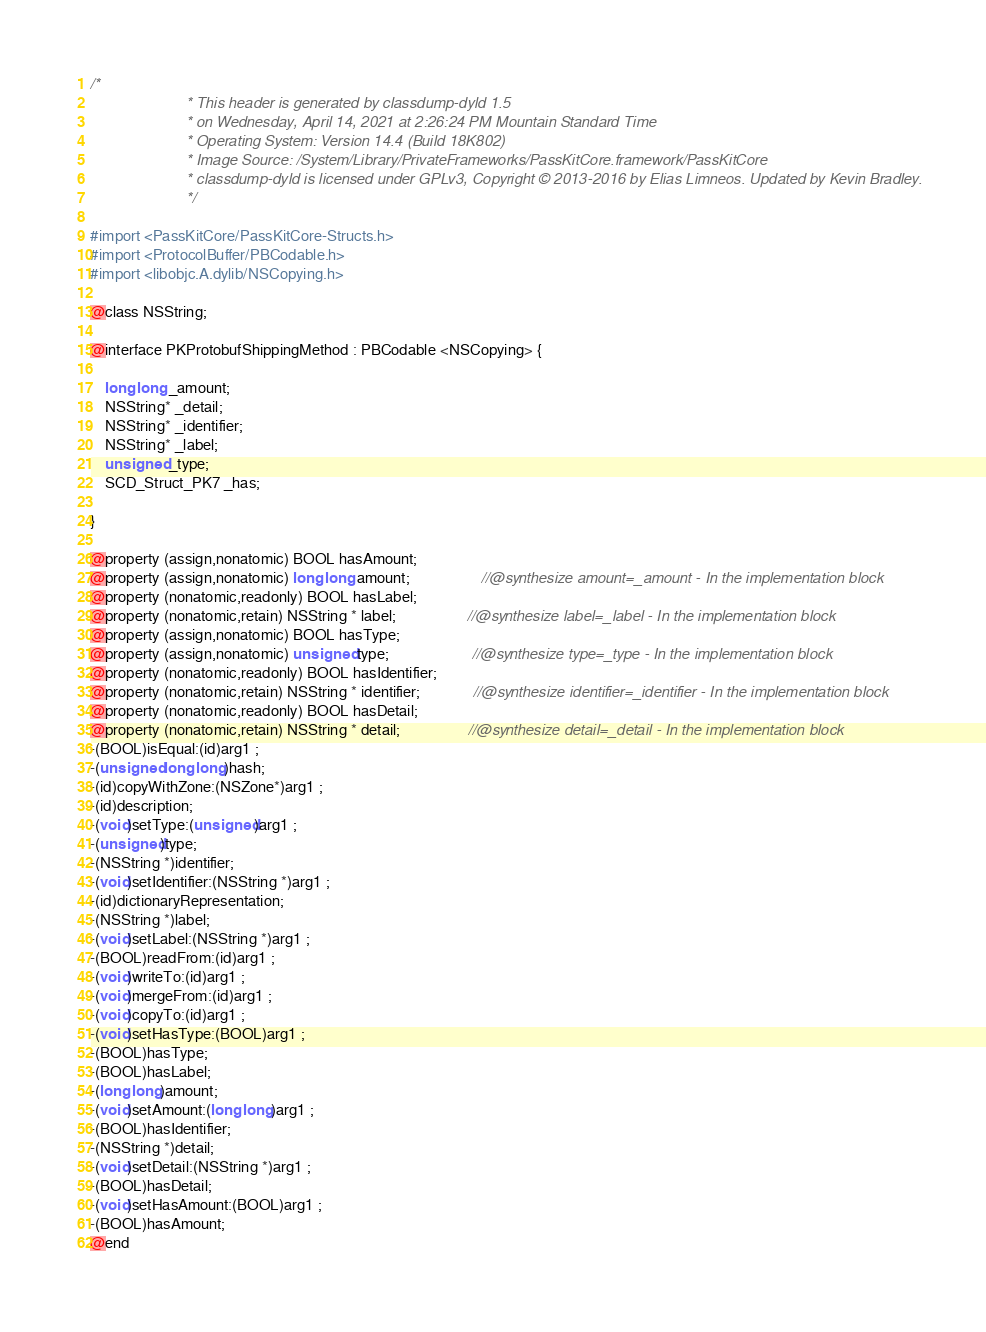<code> <loc_0><loc_0><loc_500><loc_500><_C_>/*
                       * This header is generated by classdump-dyld 1.5
                       * on Wednesday, April 14, 2021 at 2:26:24 PM Mountain Standard Time
                       * Operating System: Version 14.4 (Build 18K802)
                       * Image Source: /System/Library/PrivateFrameworks/PassKitCore.framework/PassKitCore
                       * classdump-dyld is licensed under GPLv3, Copyright © 2013-2016 by Elias Limneos. Updated by Kevin Bradley.
                       */

#import <PassKitCore/PassKitCore-Structs.h>
#import <ProtocolBuffer/PBCodable.h>
#import <libobjc.A.dylib/NSCopying.h>

@class NSString;

@interface PKProtobufShippingMethod : PBCodable <NSCopying> {

	long long _amount;
	NSString* _detail;
	NSString* _identifier;
	NSString* _label;
	unsigned _type;
	SCD_Struct_PK7 _has;

}

@property (assign,nonatomic) BOOL hasAmount; 
@property (assign,nonatomic) long long amount;                   //@synthesize amount=_amount - In the implementation block
@property (nonatomic,readonly) BOOL hasLabel; 
@property (nonatomic,retain) NSString * label;                   //@synthesize label=_label - In the implementation block
@property (assign,nonatomic) BOOL hasType; 
@property (assign,nonatomic) unsigned type;                      //@synthesize type=_type - In the implementation block
@property (nonatomic,readonly) BOOL hasIdentifier; 
@property (nonatomic,retain) NSString * identifier;              //@synthesize identifier=_identifier - In the implementation block
@property (nonatomic,readonly) BOOL hasDetail; 
@property (nonatomic,retain) NSString * detail;                  //@synthesize detail=_detail - In the implementation block
-(BOOL)isEqual:(id)arg1 ;
-(unsigned long long)hash;
-(id)copyWithZone:(NSZone*)arg1 ;
-(id)description;
-(void)setType:(unsigned)arg1 ;
-(unsigned)type;
-(NSString *)identifier;
-(void)setIdentifier:(NSString *)arg1 ;
-(id)dictionaryRepresentation;
-(NSString *)label;
-(void)setLabel:(NSString *)arg1 ;
-(BOOL)readFrom:(id)arg1 ;
-(void)writeTo:(id)arg1 ;
-(void)mergeFrom:(id)arg1 ;
-(void)copyTo:(id)arg1 ;
-(void)setHasType:(BOOL)arg1 ;
-(BOOL)hasType;
-(BOOL)hasLabel;
-(long long)amount;
-(void)setAmount:(long long)arg1 ;
-(BOOL)hasIdentifier;
-(NSString *)detail;
-(void)setDetail:(NSString *)arg1 ;
-(BOOL)hasDetail;
-(void)setHasAmount:(BOOL)arg1 ;
-(BOOL)hasAmount;
@end

</code> 